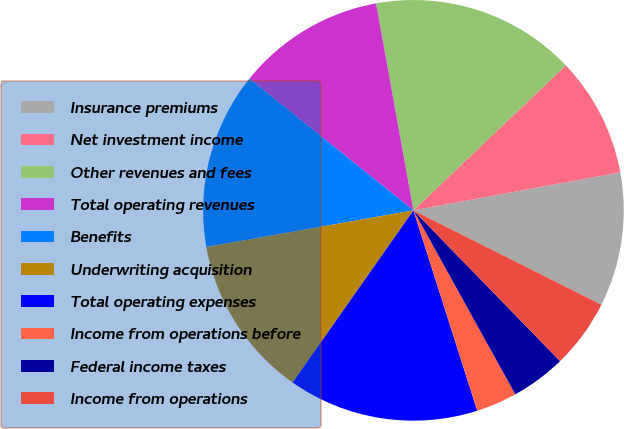Convert chart. <chart><loc_0><loc_0><loc_500><loc_500><pie_chart><fcel>Insurance premiums<fcel>Net investment income<fcel>Other revenues and fees<fcel>Total operating revenues<fcel>Benefits<fcel>Underwriting acquisition<fcel>Total operating expenses<fcel>Income from operations before<fcel>Federal income taxes<fcel>Income from operations<nl><fcel>10.3%<fcel>9.21%<fcel>15.74%<fcel>11.39%<fcel>13.56%<fcel>12.47%<fcel>14.65%<fcel>3.14%<fcel>4.23%<fcel>5.32%<nl></chart> 